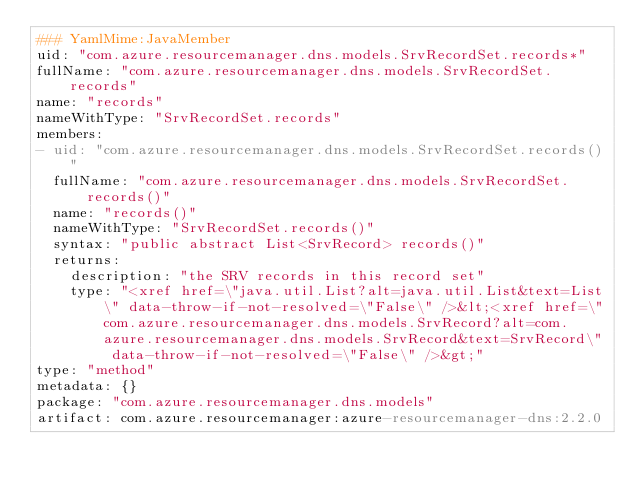Convert code to text. <code><loc_0><loc_0><loc_500><loc_500><_YAML_>### YamlMime:JavaMember
uid: "com.azure.resourcemanager.dns.models.SrvRecordSet.records*"
fullName: "com.azure.resourcemanager.dns.models.SrvRecordSet.records"
name: "records"
nameWithType: "SrvRecordSet.records"
members:
- uid: "com.azure.resourcemanager.dns.models.SrvRecordSet.records()"
  fullName: "com.azure.resourcemanager.dns.models.SrvRecordSet.records()"
  name: "records()"
  nameWithType: "SrvRecordSet.records()"
  syntax: "public abstract List<SrvRecord> records()"
  returns:
    description: "the SRV records in this record set"
    type: "<xref href=\"java.util.List?alt=java.util.List&text=List\" data-throw-if-not-resolved=\"False\" />&lt;<xref href=\"com.azure.resourcemanager.dns.models.SrvRecord?alt=com.azure.resourcemanager.dns.models.SrvRecord&text=SrvRecord\" data-throw-if-not-resolved=\"False\" />&gt;"
type: "method"
metadata: {}
package: "com.azure.resourcemanager.dns.models"
artifact: com.azure.resourcemanager:azure-resourcemanager-dns:2.2.0
</code> 